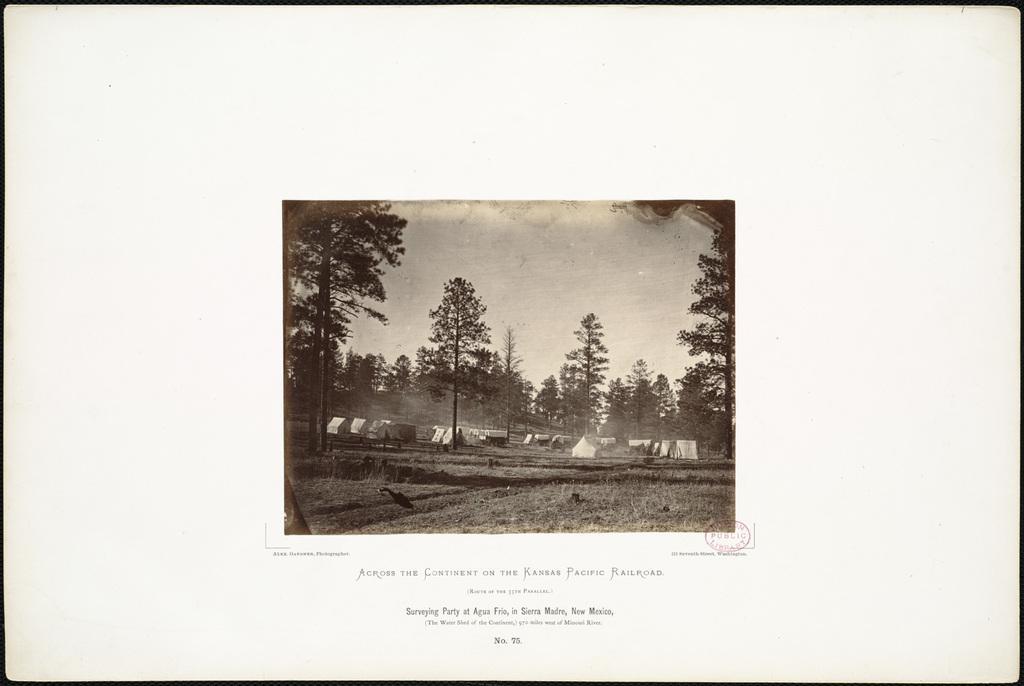Can you describe this image briefly? In this image I see the trees, ground and I see the tents over here and I can also see the sky and I see few words written over here and I see a stamp over here. 